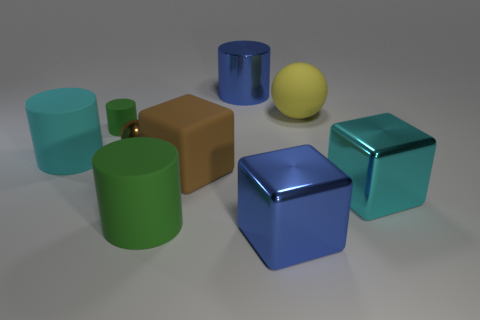Is the color of the big rubber block the same as the shiny ball?
Offer a terse response. Yes. What material is the cube that is the same color as the metallic sphere?
Ensure brevity in your answer.  Rubber. Is there a large matte object that has the same shape as the cyan metal object?
Provide a succinct answer. Yes. There is a cylinder in front of the brown rubber block; does it have the same color as the rubber object to the right of the metal cylinder?
Offer a very short reply. No. Are there any shiny things to the right of the blue cylinder?
Keep it short and to the point. Yes. What is the cylinder that is both in front of the small green rubber cylinder and behind the big rubber cube made of?
Your answer should be compact. Rubber. Do the large cyan thing to the right of the brown ball and the large brown object have the same material?
Ensure brevity in your answer.  No. What material is the big blue cylinder?
Provide a succinct answer. Metal. There is a rubber cylinder behind the cyan rubber cylinder; how big is it?
Ensure brevity in your answer.  Small. Is there any other thing of the same color as the big metallic cylinder?
Offer a terse response. Yes. 